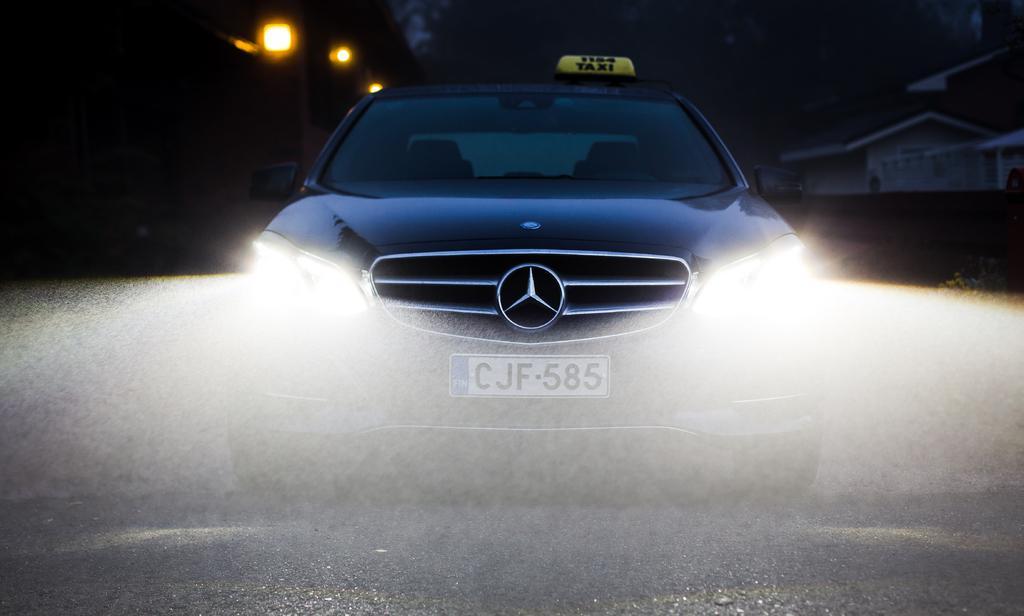Describe this image in one or two sentences. As we can see in the image there is a blue color car and lights. The number plate of this car is CJF-585 and the image is little dark. 